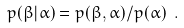Convert formula to latex. <formula><loc_0><loc_0><loc_500><loc_500>p ( \beta | \alpha ) = p ( \beta , \alpha ) / p ( \alpha ) \ .</formula> 